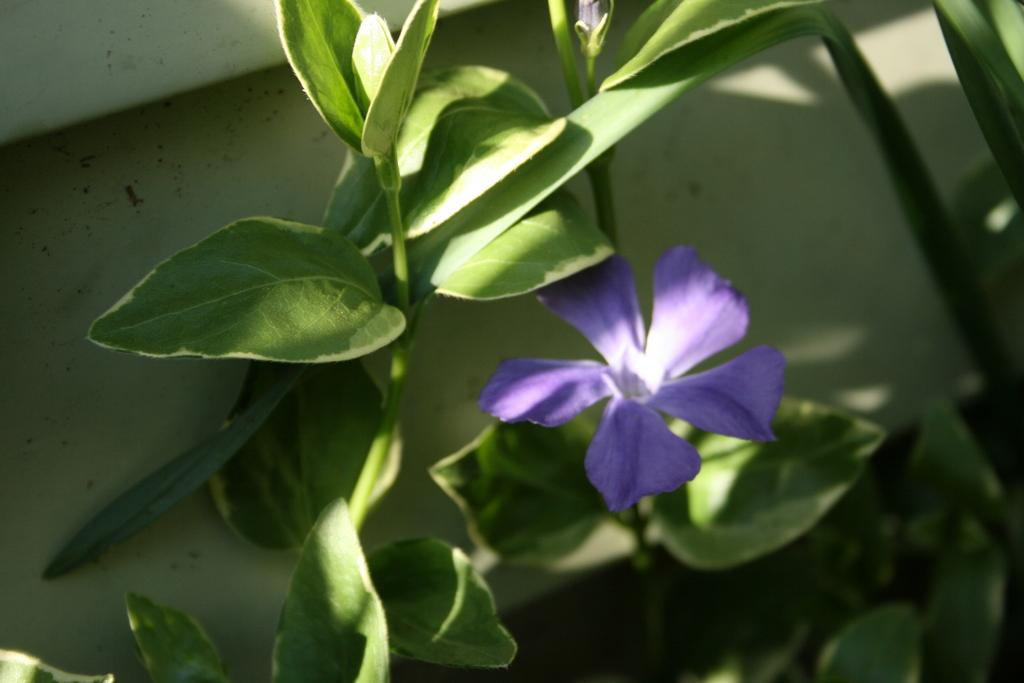What type of living organisms can be seen in the image? Plants and a flower are visible in the image. What are the colors of the flower in the image? The flower has white and purple colors. What can be seen in the background of the image? There is a white color thing in the background of the image. How many pigs are blowing bubbles in the image? There are no pigs or bubbles present in the image. 